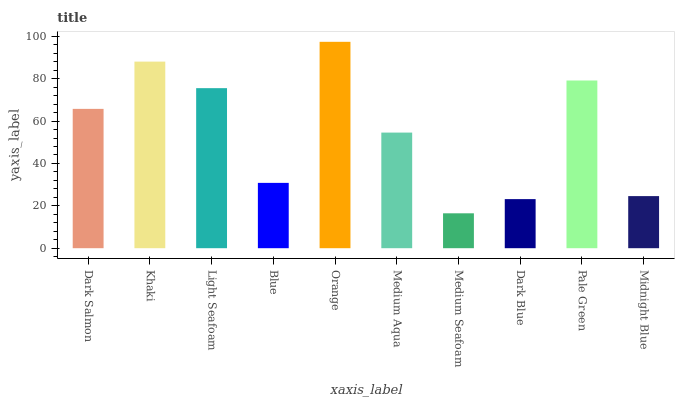Is Medium Seafoam the minimum?
Answer yes or no. Yes. Is Orange the maximum?
Answer yes or no. Yes. Is Khaki the minimum?
Answer yes or no. No. Is Khaki the maximum?
Answer yes or no. No. Is Khaki greater than Dark Salmon?
Answer yes or no. Yes. Is Dark Salmon less than Khaki?
Answer yes or no. Yes. Is Dark Salmon greater than Khaki?
Answer yes or no. No. Is Khaki less than Dark Salmon?
Answer yes or no. No. Is Dark Salmon the high median?
Answer yes or no. Yes. Is Medium Aqua the low median?
Answer yes or no. Yes. Is Light Seafoam the high median?
Answer yes or no. No. Is Midnight Blue the low median?
Answer yes or no. No. 